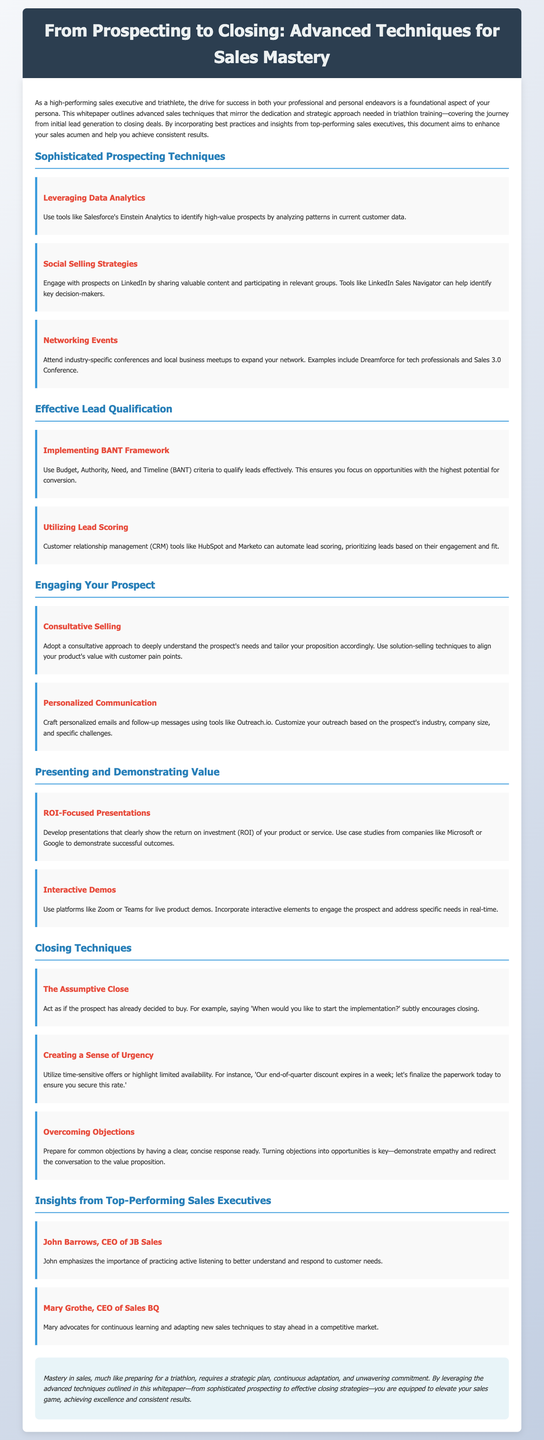What is the title of the whitepaper? The title is the primary heading at the top of the document that summarizes its content.
Answer: From Prospecting to Closing: Advanced Techniques for Sales Mastery What framework is discussed for lead qualification? The document mentions a specific methodology to assess leads based on critical criteria.
Answer: BANT Framework Who is the CEO of JB Sales? This is the name of a prominent figure mentioned in the insights section of the document.
Answer: John Barrows What is one tool suggested for social selling strategies? The document lists a tool specifically recommended for engaging with prospects on social media.
Answer: LinkedIn Sales Navigator What closing technique is referred to as creating a sense of urgency? This technique is designed to prompt immediate action and is outlined under closing strategies.
Answer: Creating a Sense of Urgency Which concept emphasizes understanding customer needs? This concept is highlighted as important for engaging prospects effectively in the selling process.
Answer: Consultative Selling What is emphasized by Mary Grothe for staying ahead in sales? This point reflects her advice on the importance of adapting to changes in the sales environment.
Answer: Continuous learning What type of presentations does the document recommend? This specific type focuses on demonstrating a clear financial benefit to prospects.
Answer: ROI-Focused Presentations 